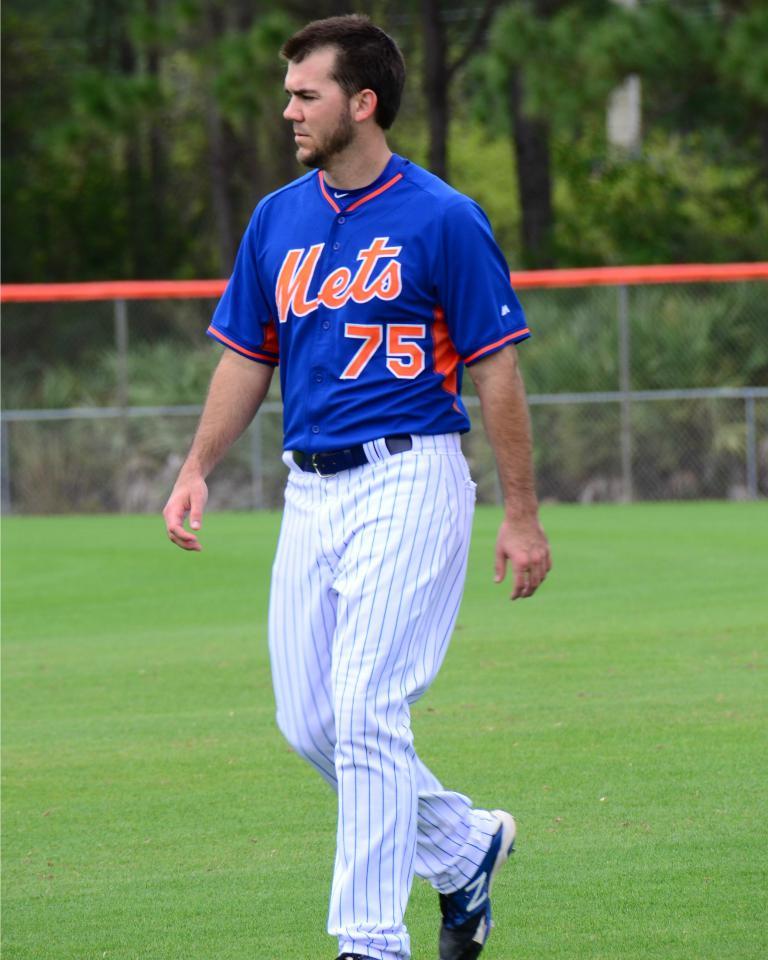What team does he play for?
Provide a succinct answer. Mets. 